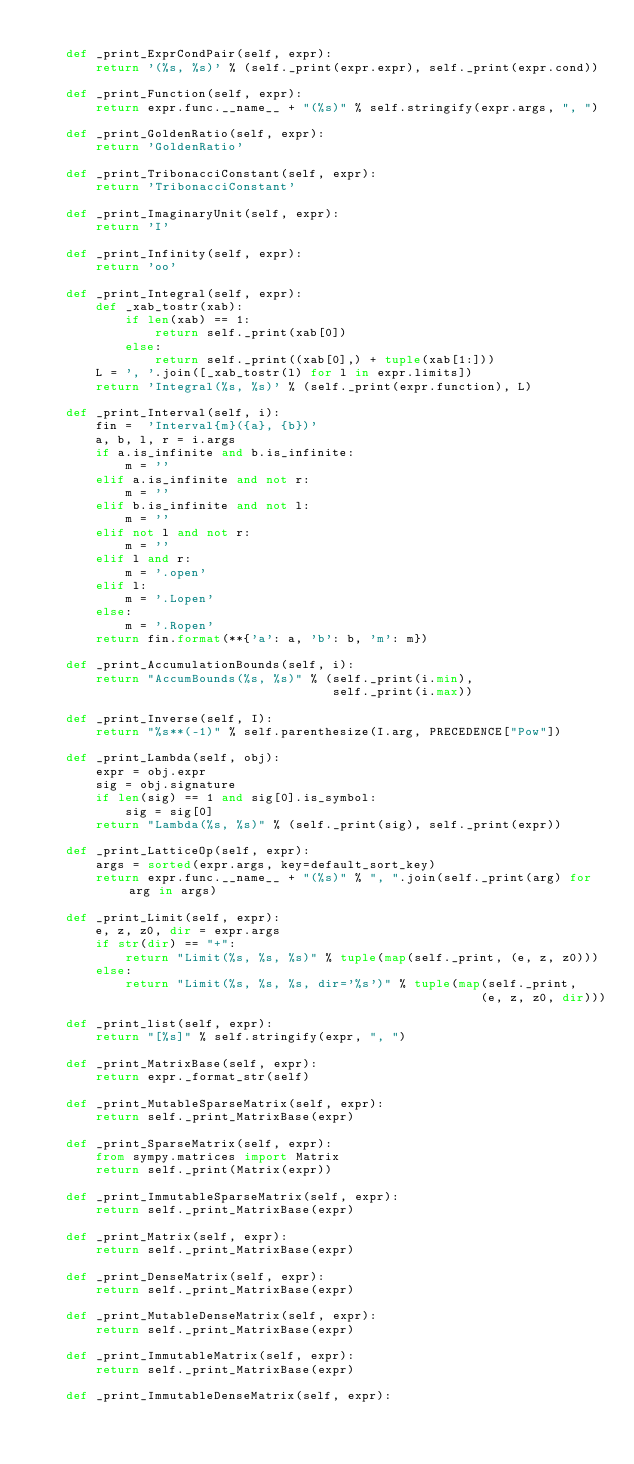Convert code to text. <code><loc_0><loc_0><loc_500><loc_500><_Python_>
    def _print_ExprCondPair(self, expr):
        return '(%s, %s)' % (self._print(expr.expr), self._print(expr.cond))

    def _print_Function(self, expr):
        return expr.func.__name__ + "(%s)" % self.stringify(expr.args, ", ")

    def _print_GoldenRatio(self, expr):
        return 'GoldenRatio'

    def _print_TribonacciConstant(self, expr):
        return 'TribonacciConstant'

    def _print_ImaginaryUnit(self, expr):
        return 'I'

    def _print_Infinity(self, expr):
        return 'oo'

    def _print_Integral(self, expr):
        def _xab_tostr(xab):
            if len(xab) == 1:
                return self._print(xab[0])
            else:
                return self._print((xab[0],) + tuple(xab[1:]))
        L = ', '.join([_xab_tostr(l) for l in expr.limits])
        return 'Integral(%s, %s)' % (self._print(expr.function), L)

    def _print_Interval(self, i):
        fin =  'Interval{m}({a}, {b})'
        a, b, l, r = i.args
        if a.is_infinite and b.is_infinite:
            m = ''
        elif a.is_infinite and not r:
            m = ''
        elif b.is_infinite and not l:
            m = ''
        elif not l and not r:
            m = ''
        elif l and r:
            m = '.open'
        elif l:
            m = '.Lopen'
        else:
            m = '.Ropen'
        return fin.format(**{'a': a, 'b': b, 'm': m})

    def _print_AccumulationBounds(self, i):
        return "AccumBounds(%s, %s)" % (self._print(i.min),
                                        self._print(i.max))

    def _print_Inverse(self, I):
        return "%s**(-1)" % self.parenthesize(I.arg, PRECEDENCE["Pow"])

    def _print_Lambda(self, obj):
        expr = obj.expr
        sig = obj.signature
        if len(sig) == 1 and sig[0].is_symbol:
            sig = sig[0]
        return "Lambda(%s, %s)" % (self._print(sig), self._print(expr))

    def _print_LatticeOp(self, expr):
        args = sorted(expr.args, key=default_sort_key)
        return expr.func.__name__ + "(%s)" % ", ".join(self._print(arg) for arg in args)

    def _print_Limit(self, expr):
        e, z, z0, dir = expr.args
        if str(dir) == "+":
            return "Limit(%s, %s, %s)" % tuple(map(self._print, (e, z, z0)))
        else:
            return "Limit(%s, %s, %s, dir='%s')" % tuple(map(self._print,
                                                            (e, z, z0, dir)))

    def _print_list(self, expr):
        return "[%s]" % self.stringify(expr, ", ")

    def _print_MatrixBase(self, expr):
        return expr._format_str(self)

    def _print_MutableSparseMatrix(self, expr):
        return self._print_MatrixBase(expr)

    def _print_SparseMatrix(self, expr):
        from sympy.matrices import Matrix
        return self._print(Matrix(expr))

    def _print_ImmutableSparseMatrix(self, expr):
        return self._print_MatrixBase(expr)

    def _print_Matrix(self, expr):
        return self._print_MatrixBase(expr)

    def _print_DenseMatrix(self, expr):
        return self._print_MatrixBase(expr)

    def _print_MutableDenseMatrix(self, expr):
        return self._print_MatrixBase(expr)

    def _print_ImmutableMatrix(self, expr):
        return self._print_MatrixBase(expr)

    def _print_ImmutableDenseMatrix(self, expr):</code> 